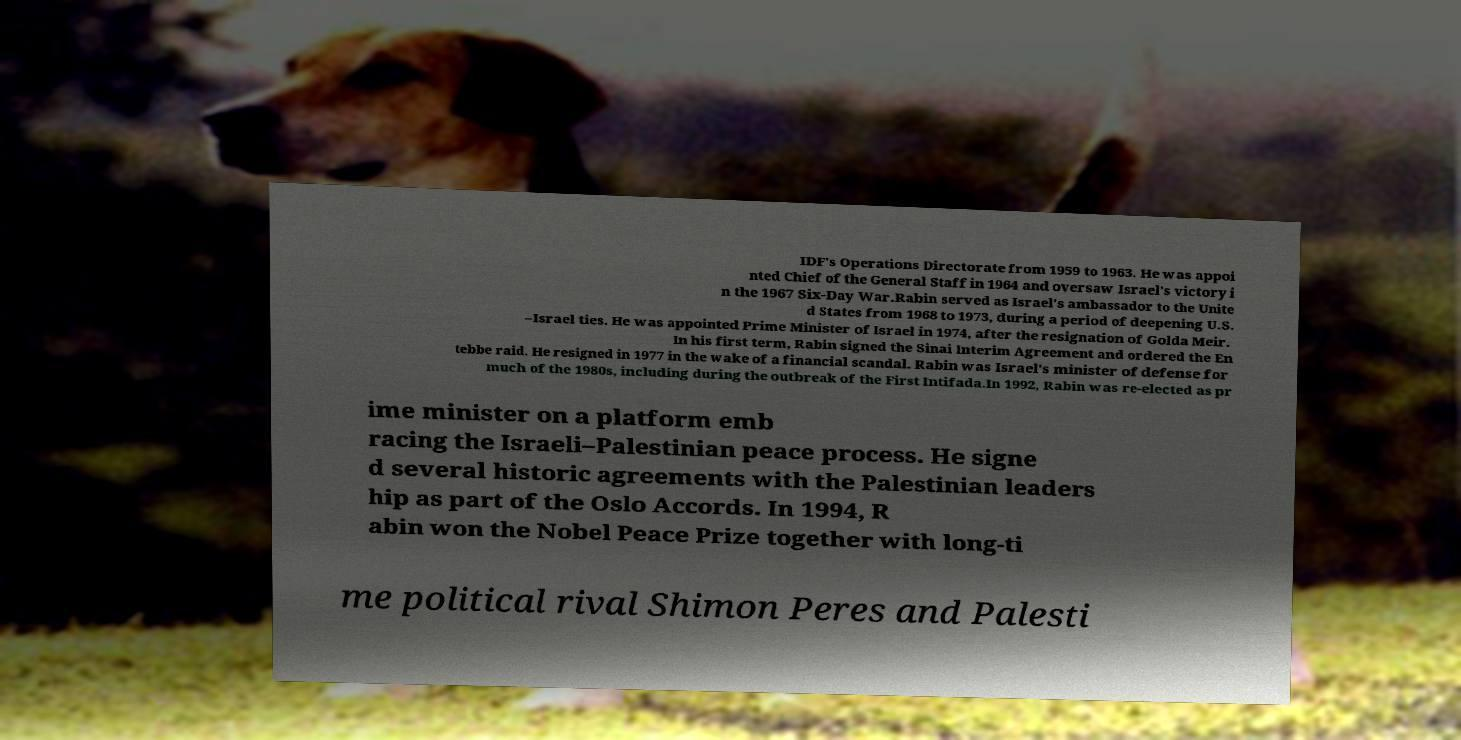Please read and relay the text visible in this image. What does it say? IDF's Operations Directorate from 1959 to 1963. He was appoi nted Chief of the General Staff in 1964 and oversaw Israel's victory i n the 1967 Six-Day War.Rabin served as Israel's ambassador to the Unite d States from 1968 to 1973, during a period of deepening U.S. –Israel ties. He was appointed Prime Minister of Israel in 1974, after the resignation of Golda Meir. In his first term, Rabin signed the Sinai Interim Agreement and ordered the En tebbe raid. He resigned in 1977 in the wake of a financial scandal. Rabin was Israel's minister of defense for much of the 1980s, including during the outbreak of the First Intifada.In 1992, Rabin was re-elected as pr ime minister on a platform emb racing the Israeli–Palestinian peace process. He signe d several historic agreements with the Palestinian leaders hip as part of the Oslo Accords. In 1994, R abin won the Nobel Peace Prize together with long-ti me political rival Shimon Peres and Palesti 